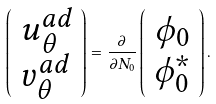<formula> <loc_0><loc_0><loc_500><loc_500>\left ( \begin{array} { c } u ^ { a d } _ { \theta } \\ v ^ { a d } _ { \theta } \end{array} \right ) = \frac { \partial } { \partial N _ { 0 } } \left ( \begin{array} { c } \phi _ { 0 } \\ \phi _ { 0 } ^ { * } \end{array} \right ) .</formula> 